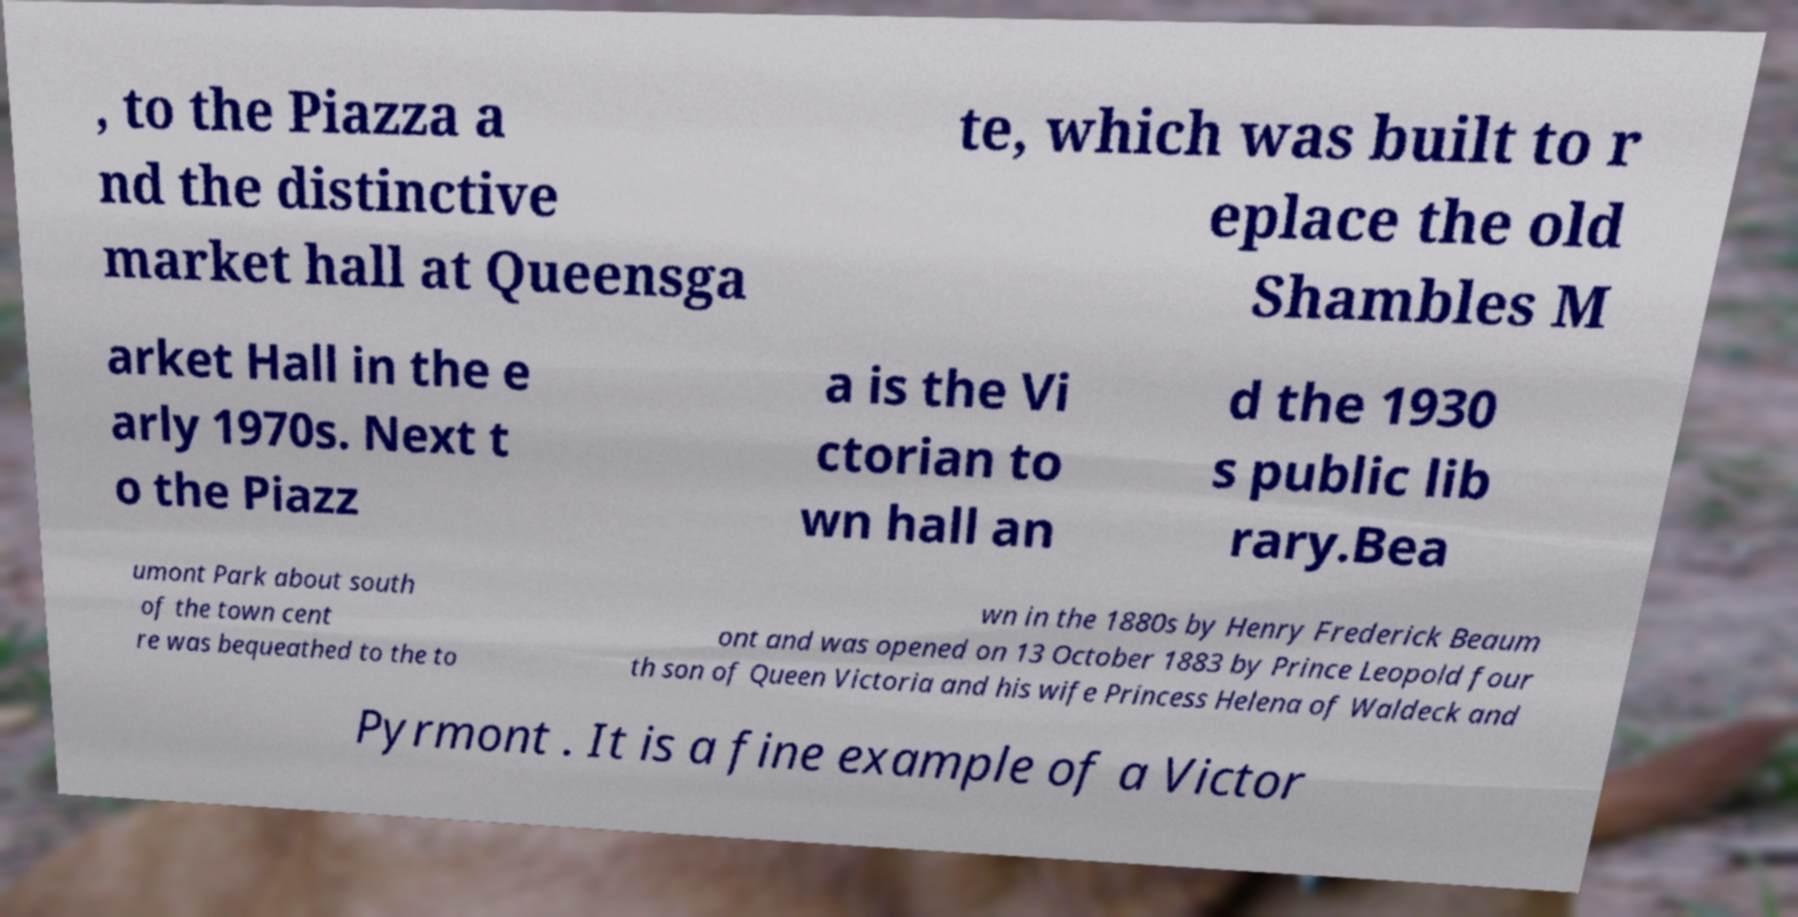Can you read and provide the text displayed in the image?This photo seems to have some interesting text. Can you extract and type it out for me? , to the Piazza a nd the distinctive market hall at Queensga te, which was built to r eplace the old Shambles M arket Hall in the e arly 1970s. Next t o the Piazz a is the Vi ctorian to wn hall an d the 1930 s public lib rary.Bea umont Park about south of the town cent re was bequeathed to the to wn in the 1880s by Henry Frederick Beaum ont and was opened on 13 October 1883 by Prince Leopold four th son of Queen Victoria and his wife Princess Helena of Waldeck and Pyrmont . It is a fine example of a Victor 